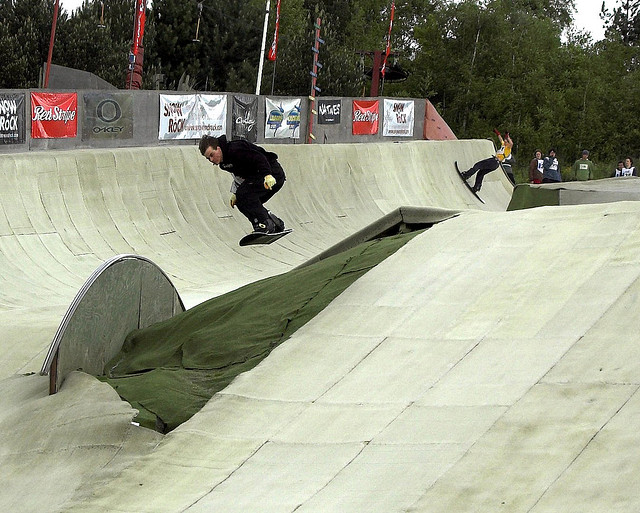<image>Where is his head protection? I don't know where his head protection is. It appears he is not wearing any. Where is his head protection? I don't know where his head protection is. He might not have it or he is not wearing any. It can also be lost or not on his head. 